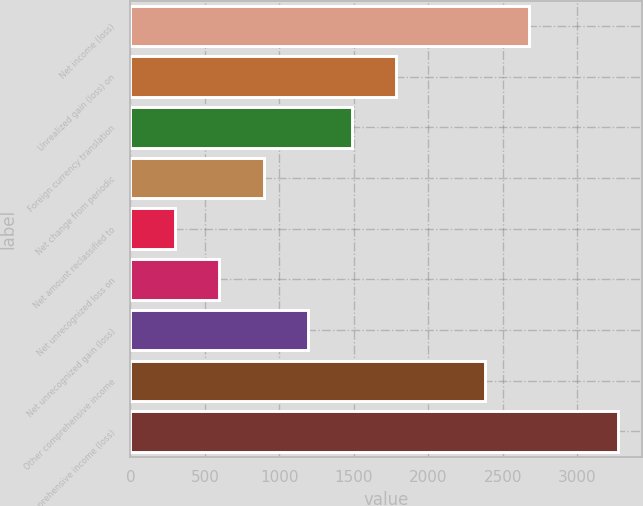Convert chart to OTSL. <chart><loc_0><loc_0><loc_500><loc_500><bar_chart><fcel>Net income (loss)<fcel>Unrealized gain (loss) on<fcel>Foreign currency translation<fcel>Net change from periodic<fcel>Net amount reclassified to<fcel>Net unrecognized loss on<fcel>Net unrecognized gain (loss)<fcel>Other comprehensive income<fcel>Comprehensive income (loss)<nl><fcel>2677.9<fcel>1786.6<fcel>1489.5<fcel>895.3<fcel>301.1<fcel>598.2<fcel>1192.4<fcel>2380.8<fcel>3272.1<nl></chart> 